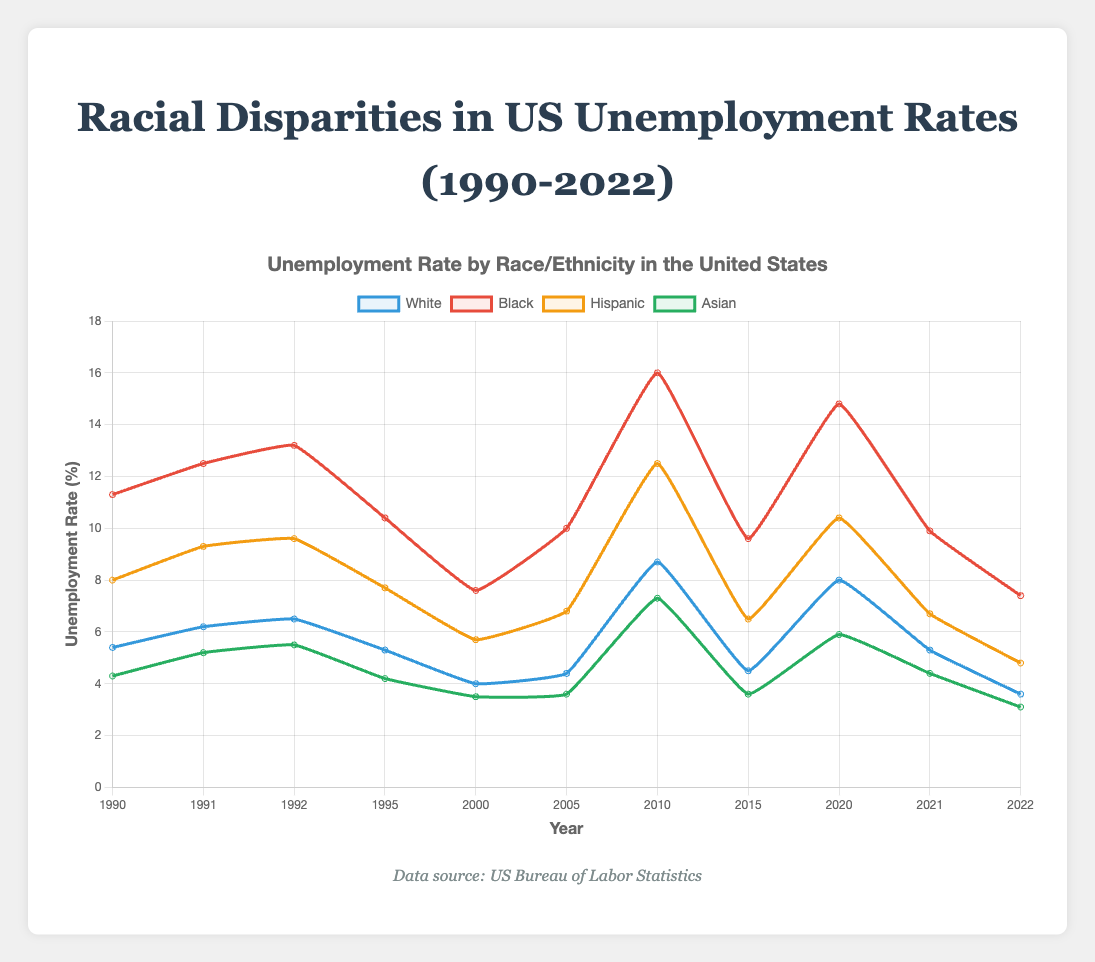What's the highest unemployment rate for Black individuals and in which year? To find the highest unemployment rate for Black individuals, look at the data points for "Black" and identify the year with the maximum value. The peak value is 16.0% in 2010.
Answer: 16.0% in 2010 How did the unemployment rates for Hispanic individuals change from 1992 to 1995? Compare the unemployment rates for Hispanic individuals in 1992 (9.6%) and in 1995 (7.7%). Calculate the difference: 9.6% - 7.7% = 1.9%. The unemployment rate decreased by 1.9%.
Answer: Decreased by 1.9% Which racial group had the lowest unemployment rate in 2022? Look at the unemployment rates for all racial groups in 2022: White (3.6%), Black (7.4%), Hispanic (4.8%), and Asian (3.1%). The lowest rate is 3.1%, which is for Asian individuals.
Answer: Asian During which periods did the unemployment rate for White individuals surpass 8.0%? Identify the years when the unemployment rate for White individuals was above 8.0%. The two years are 2010 (8.7%) and 2020 (8.0%).
Answer: 2010 and 2020 What is the average unemployment rate for Asian individuals over the period from 1990 to 2000? To find the average, sum the unemployment rates for Asian individuals from 1990 (4.3%), 1991 (5.2%), 1992 (5.5%), 1995 (4.2%), and 2000 (3.5%). The sum is 4.3 + 5.2 + 5.5 + 4.2 + 3.5 = 22.7. Divide by the number of years: 22.7/5 = 4.54%.
Answer: 4.54% Which racial group experienced the most significant relative increase in unemployment rate between 2005 and 2010? Compare the unemployment rates for each racial group in 2005 and 2010, then calculate the relative increases. White: (8.7-4.4)/4.4 = 97.7%, Black: (16.0-10.0)/10.0 = 60%, Hispanic: (12.5-6.8)/6.8 = 83.8%, Asian: (7.3-3.6)/3.6 = 102.8%. The most significant relative increase was for Asian individuals.
Answer: Asian What is the median unemployment rate for Black individuals from 1990 to 2022? To find the median, list the unemployment rates for Black individuals in ascending order: 7.4, 7.6, 9.6, 9.9, 10.0, 10.4, 11.3, 12.5, 13.2, 14.8, 16.0. The median value is the middle value: 10.4.
Answer: 10.4 In which year did the unemployment rate for Hispanic individuals first exceed 8.0%? Check the unemployment rates for Hispanic individuals year by year and identify when it first exceeds 8.0%. It first exceeded 8.0% in 1991 (9.3%).
Answer: 1991 